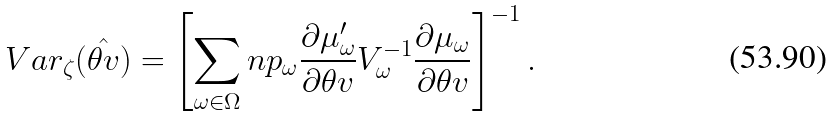Convert formula to latex. <formula><loc_0><loc_0><loc_500><loc_500>V a r _ { \zeta } ( \hat { \theta v } ) = \left [ \sum _ { \omega \in \Omega } n p _ { \omega } \frac { \partial \mu ^ { \prime } _ { \omega } } { \partial \theta v } V _ { \omega } ^ { - 1 } \frac { \partial \mu _ { \omega } } { \partial \theta v } \right ] ^ { - 1 } .</formula> 